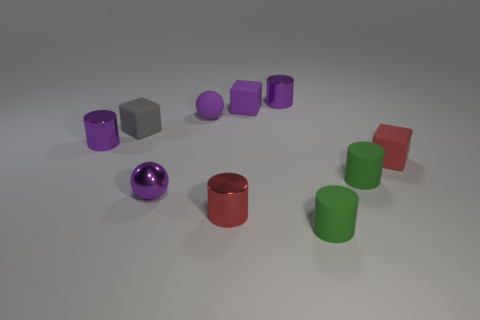Subtract all purple shiny cylinders. How many cylinders are left? 3 Subtract all red cylinders. How many cylinders are left? 4 Subtract all blocks. How many objects are left? 7 Subtract 2 cylinders. How many cylinders are left? 3 Subtract all brown balls. Subtract all cyan blocks. How many balls are left? 2 Add 2 tiny purple metal balls. How many tiny purple metal balls are left? 3 Add 2 red cylinders. How many red cylinders exist? 3 Subtract 0 green spheres. How many objects are left? 10 Subtract all purple spheres. How many blue cubes are left? 0 Subtract all tiny purple balls. Subtract all small purple things. How many objects are left? 3 